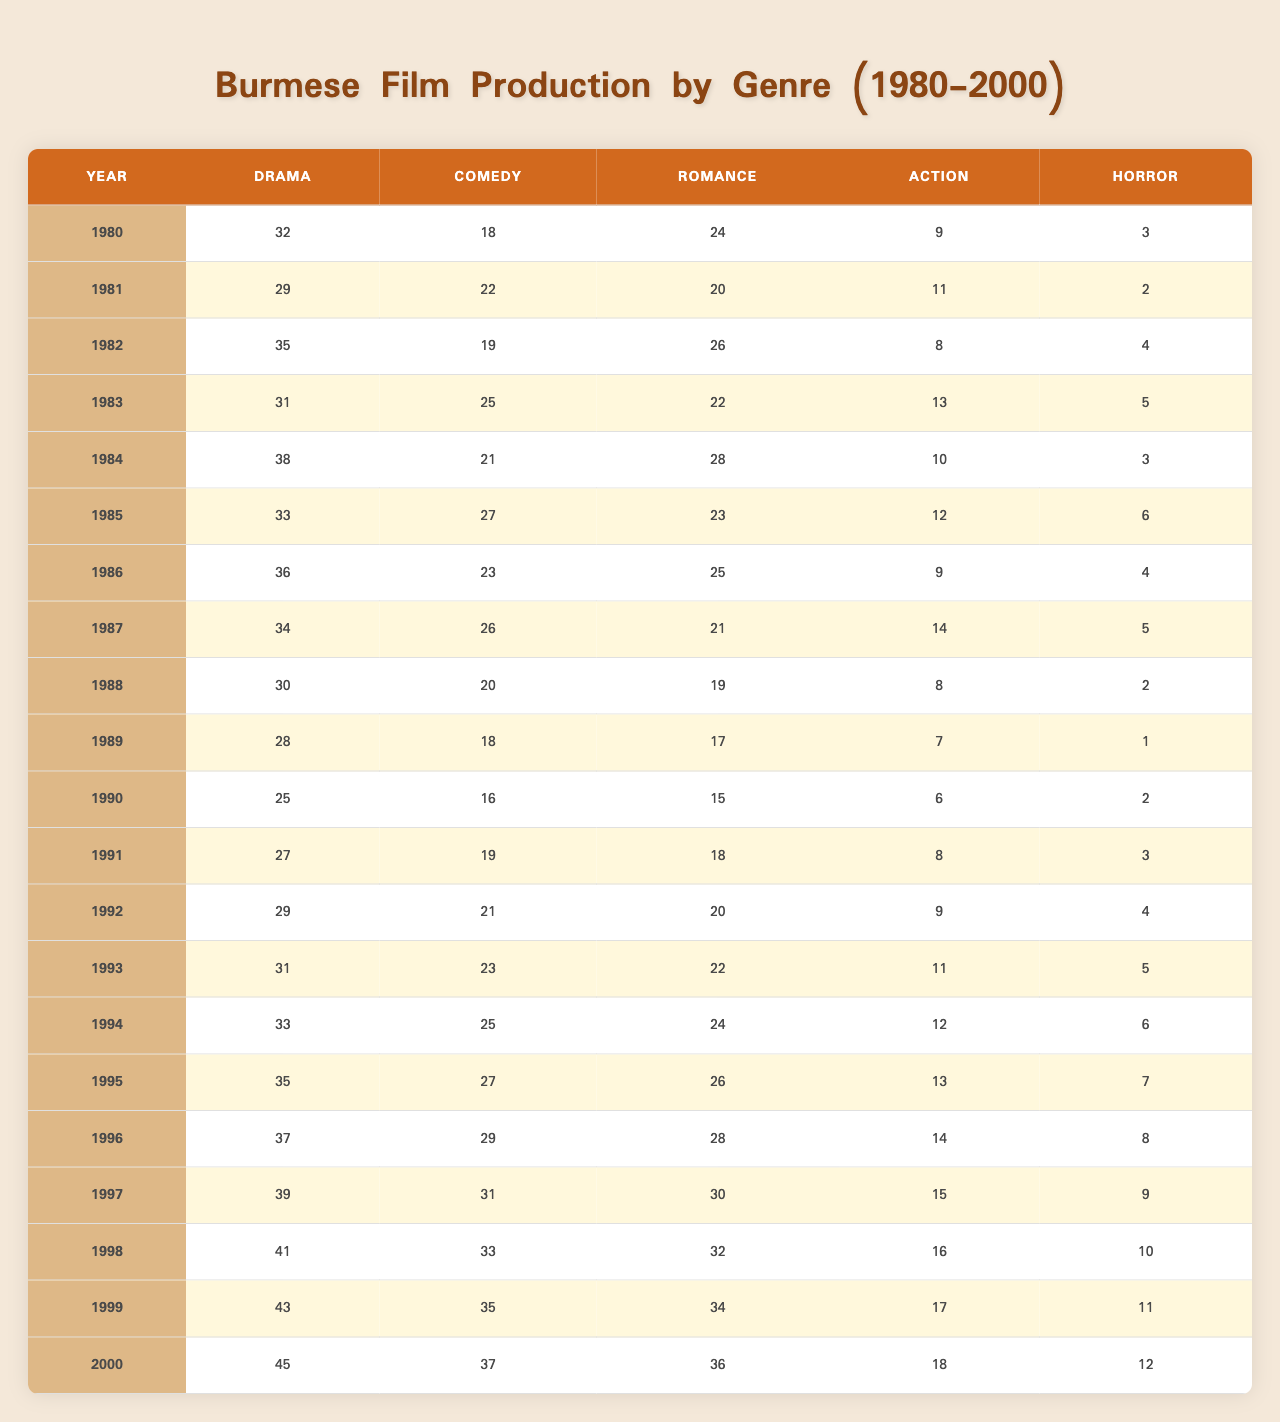What was the highest production count for horror films in any year between 1980 and 2000? Looking at the horror film column, the highest value is 12 in the year 2000.
Answer: 12 In which year did Burmese film production of drama reach its peak? The drama column shows that the highest production count is 45 in the year 2000, indicating the peak production year for drama.
Answer: 2000 Which genre had the least number of films produced in 1985? For the year 1985, the horror genre has the lowest production count at 6 films.
Answer: Horror Calculate the average number of comedy films produced from 1990 to 1995. We sum the comedy film productions from 1990 to 1995: (16 + 19 + 21 + 23 + 25 + 27) = 131, then divide by 6 (the number of years) gives 131/6 = 21.83, rounded down to 21.
Answer: 21 In which year did both drama and action productions decrease compared to the previous year? The years 1982 (Drama from 35 to 31, Action from 8 to 13) and 1985 (Drama from 33 to 38, Action from 12 to 10) show declines for both genres from the respective previous years.
Answer: 1983 and 1985 Did the number of action films produced ever exceed the number of horror films in any year from 1980 to 2000? Yes, every year from 1980 to 2000 had more action films produced than horror films, confirming that the action genre consistently had higher production counts.
Answer: Yes What is the total production count for romance films in the years 1998 to 2000? The production counts for romance from 1998 to 2000 are 32 (1998), 34 (1999), and 36 (2000). Summing these gives 32 + 34 + 36 = 102.
Answer: 102 Was there a year when the production of comedy films was equal to the production of drama films? Yes, in the year 1981, comedy films had 22 productions, which matched the drama film production for that year.
Answer: Yes Calculate the difference in the number of drama films produced in 1980 and 2000. The drama productions in 1980 were 32 and in 2000 were 45. The difference is 45 - 32 = 13.
Answer: 13 Which genre saw the largest increase in production count from 1980 to 2000? Comparing the production counts, drama increased from 32 in 1980 to 45 in 2000, which is a 13 film increase—the largest compared to other genres.
Answer: Drama 